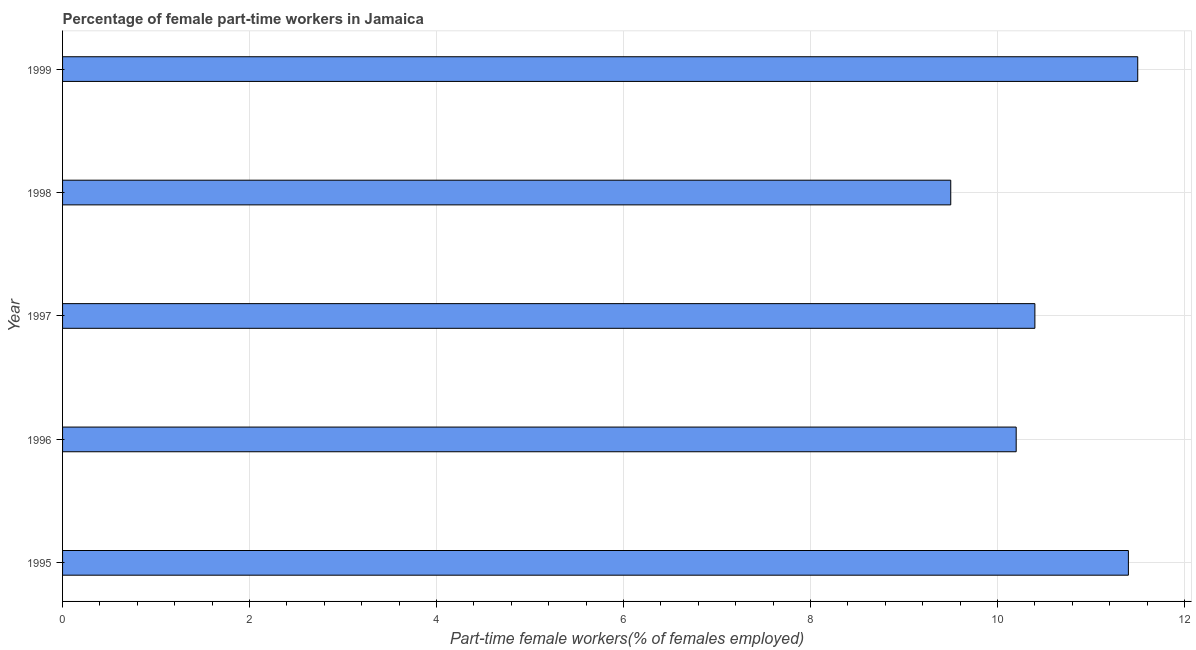Does the graph contain any zero values?
Your answer should be compact. No. Does the graph contain grids?
Ensure brevity in your answer.  Yes. What is the title of the graph?
Keep it short and to the point. Percentage of female part-time workers in Jamaica. What is the label or title of the X-axis?
Provide a succinct answer. Part-time female workers(% of females employed). What is the label or title of the Y-axis?
Provide a short and direct response. Year. What is the percentage of part-time female workers in 1997?
Provide a short and direct response. 10.4. In which year was the percentage of part-time female workers maximum?
Provide a short and direct response. 1999. What is the sum of the percentage of part-time female workers?
Make the answer very short. 53. What is the median percentage of part-time female workers?
Make the answer very short. 10.4. Do a majority of the years between 1998 and 1996 (inclusive) have percentage of part-time female workers greater than 9.2 %?
Offer a terse response. Yes. What is the ratio of the percentage of part-time female workers in 1998 to that in 1999?
Your answer should be compact. 0.83. Is the percentage of part-time female workers in 1996 less than that in 1999?
Offer a very short reply. Yes. What is the difference between the highest and the second highest percentage of part-time female workers?
Ensure brevity in your answer.  0.1. Is the sum of the percentage of part-time female workers in 1997 and 1998 greater than the maximum percentage of part-time female workers across all years?
Ensure brevity in your answer.  Yes. How many bars are there?
Give a very brief answer. 5. Are all the bars in the graph horizontal?
Make the answer very short. Yes. How many years are there in the graph?
Give a very brief answer. 5. What is the difference between two consecutive major ticks on the X-axis?
Give a very brief answer. 2. What is the Part-time female workers(% of females employed) in 1995?
Your response must be concise. 11.4. What is the Part-time female workers(% of females employed) of 1996?
Ensure brevity in your answer.  10.2. What is the Part-time female workers(% of females employed) of 1997?
Ensure brevity in your answer.  10.4. What is the Part-time female workers(% of females employed) of 1998?
Keep it short and to the point. 9.5. What is the Part-time female workers(% of females employed) in 1999?
Provide a short and direct response. 11.5. What is the difference between the Part-time female workers(% of females employed) in 1995 and 1998?
Provide a short and direct response. 1.9. What is the difference between the Part-time female workers(% of females employed) in 1995 and 1999?
Offer a very short reply. -0.1. What is the difference between the Part-time female workers(% of females employed) in 1996 and 1998?
Your answer should be very brief. 0.7. What is the difference between the Part-time female workers(% of females employed) in 1997 and 1998?
Make the answer very short. 0.9. What is the difference between the Part-time female workers(% of females employed) in 1997 and 1999?
Ensure brevity in your answer.  -1.1. What is the ratio of the Part-time female workers(% of females employed) in 1995 to that in 1996?
Keep it short and to the point. 1.12. What is the ratio of the Part-time female workers(% of females employed) in 1995 to that in 1997?
Provide a short and direct response. 1.1. What is the ratio of the Part-time female workers(% of females employed) in 1995 to that in 1999?
Give a very brief answer. 0.99. What is the ratio of the Part-time female workers(% of females employed) in 1996 to that in 1998?
Ensure brevity in your answer.  1.07. What is the ratio of the Part-time female workers(% of females employed) in 1996 to that in 1999?
Provide a succinct answer. 0.89. What is the ratio of the Part-time female workers(% of females employed) in 1997 to that in 1998?
Provide a short and direct response. 1.09. What is the ratio of the Part-time female workers(% of females employed) in 1997 to that in 1999?
Provide a succinct answer. 0.9. What is the ratio of the Part-time female workers(% of females employed) in 1998 to that in 1999?
Offer a very short reply. 0.83. 